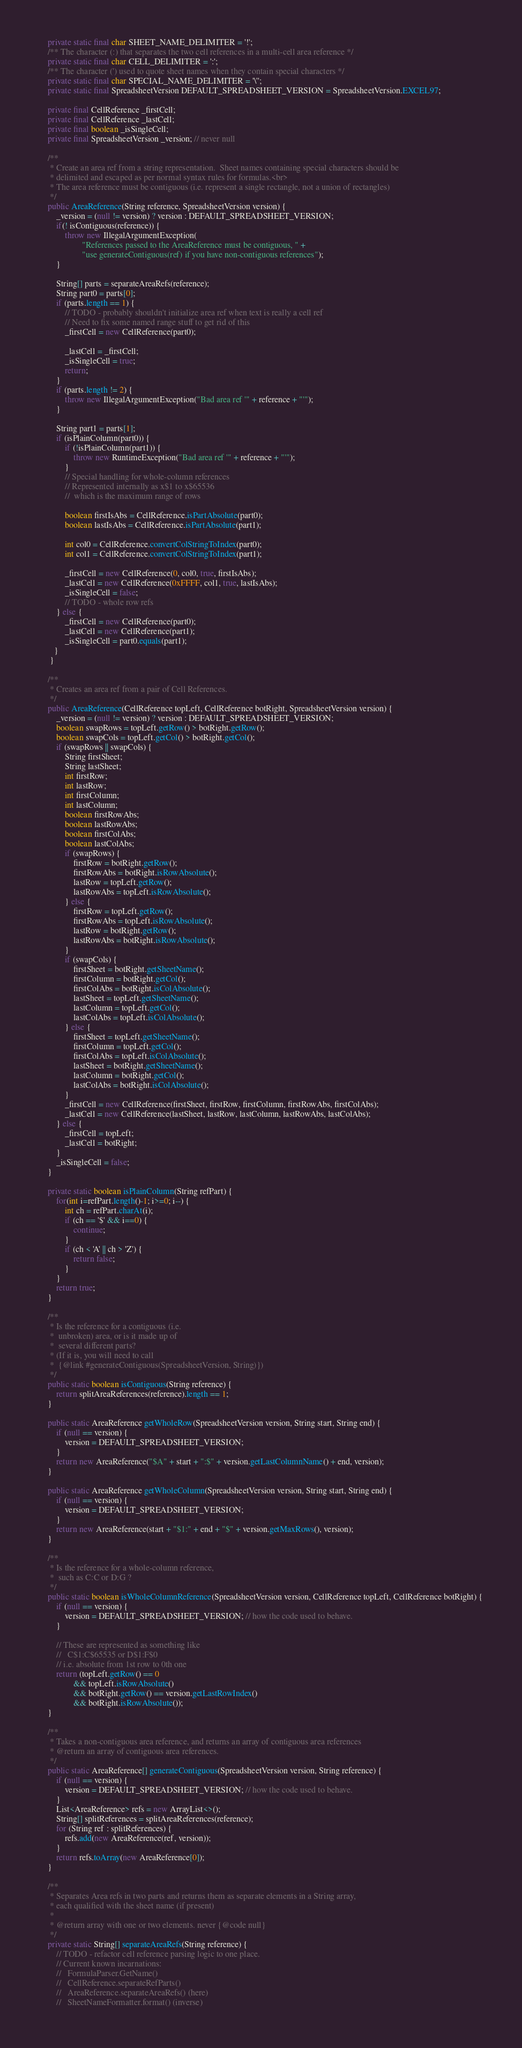<code> <loc_0><loc_0><loc_500><loc_500><_Java_>    private static final char SHEET_NAME_DELIMITER = '!';
    /** The character (:) that separates the two cell references in a multi-cell area reference */
    private static final char CELL_DELIMITER = ':';
    /** The character (') used to quote sheet names when they contain special characters */
    private static final char SPECIAL_NAME_DELIMITER = '\'';
    private static final SpreadsheetVersion DEFAULT_SPREADSHEET_VERSION = SpreadsheetVersion.EXCEL97;

    private final CellReference _firstCell;
    private final CellReference _lastCell;
    private final boolean _isSingleCell;
    private final SpreadsheetVersion _version; // never null

    /**
     * Create an area ref from a string representation.  Sheet names containing special characters should be
     * delimited and escaped as per normal syntax rules for formulas.<br>
     * The area reference must be contiguous (i.e. represent a single rectangle, not a union of rectangles)
     */
    public AreaReference(String reference, SpreadsheetVersion version) {
        _version = (null != version) ? version : DEFAULT_SPREADSHEET_VERSION;
        if(! isContiguous(reference)) {
            throw new IllegalArgumentException(
                    "References passed to the AreaReference must be contiguous, " +
                    "use generateContiguous(ref) if you have non-contiguous references");
        }

        String[] parts = separateAreaRefs(reference);
        String part0 = parts[0];
        if (parts.length == 1) {
            // TODO - probably shouldn't initialize area ref when text is really a cell ref
            // Need to fix some named range stuff to get rid of this
            _firstCell = new CellReference(part0);

            _lastCell = _firstCell;
            _isSingleCell = true;
            return;
        }
        if (parts.length != 2) {
            throw new IllegalArgumentException("Bad area ref '" + reference + "'");
        }

        String part1 = parts[1];
        if (isPlainColumn(part0)) {
            if (!isPlainColumn(part1)) {
                throw new RuntimeException("Bad area ref '" + reference + "'");
            }
            // Special handling for whole-column references
            // Represented internally as x$1 to x$65536
            //  which is the maximum range of rows

            boolean firstIsAbs = CellReference.isPartAbsolute(part0);
            boolean lastIsAbs = CellReference.isPartAbsolute(part1);

            int col0 = CellReference.convertColStringToIndex(part0);
            int col1 = CellReference.convertColStringToIndex(part1);

            _firstCell = new CellReference(0, col0, true, firstIsAbs);
            _lastCell = new CellReference(0xFFFF, col1, true, lastIsAbs);
            _isSingleCell = false;
            // TODO - whole row refs
        } else {
            _firstCell = new CellReference(part0);
            _lastCell = new CellReference(part1);
            _isSingleCell = part0.equals(part1);
       }
     }

    /**
     * Creates an area ref from a pair of Cell References.
     */
    public AreaReference(CellReference topLeft, CellReference botRight, SpreadsheetVersion version) {
        _version = (null != version) ? version : DEFAULT_SPREADSHEET_VERSION;
        boolean swapRows = topLeft.getRow() > botRight.getRow();
        boolean swapCols = topLeft.getCol() > botRight.getCol();
        if (swapRows || swapCols) {
            String firstSheet;
            String lastSheet;
            int firstRow;
            int lastRow;
            int firstColumn;
            int lastColumn;
            boolean firstRowAbs;
            boolean lastRowAbs;
            boolean firstColAbs;
            boolean lastColAbs;
            if (swapRows) {
                firstRow = botRight.getRow();
                firstRowAbs = botRight.isRowAbsolute();
                lastRow = topLeft.getRow();
                lastRowAbs = topLeft.isRowAbsolute();
            } else {
                firstRow = topLeft.getRow();
                firstRowAbs = topLeft.isRowAbsolute();
                lastRow = botRight.getRow();
                lastRowAbs = botRight.isRowAbsolute();
            }
            if (swapCols) {
                firstSheet = botRight.getSheetName();
                firstColumn = botRight.getCol();
                firstColAbs = botRight.isColAbsolute();
                lastSheet = topLeft.getSheetName();
                lastColumn = topLeft.getCol();
                lastColAbs = topLeft.isColAbsolute();
            } else {
                firstSheet = topLeft.getSheetName();
                firstColumn = topLeft.getCol();
                firstColAbs = topLeft.isColAbsolute();
                lastSheet = botRight.getSheetName();
                lastColumn = botRight.getCol();
                lastColAbs = botRight.isColAbsolute();
            }
            _firstCell = new CellReference(firstSheet, firstRow, firstColumn, firstRowAbs, firstColAbs);
            _lastCell = new CellReference(lastSheet, lastRow, lastColumn, lastRowAbs, lastColAbs);
        } else {
            _firstCell = topLeft;
            _lastCell = botRight;
        }
        _isSingleCell = false;
    }

    private static boolean isPlainColumn(String refPart) {
        for(int i=refPart.length()-1; i>=0; i--) {
            int ch = refPart.charAt(i);
            if (ch == '$' && i==0) {
                continue;
            }
            if (ch < 'A' || ch > 'Z') {
                return false;
            }
        }
        return true;
    }

    /**
     * Is the reference for a contiguous (i.e.
     *  unbroken) area, or is it made up of
     *  several different parts?
     * (If it is, you will need to call
     *  {@link #generateContiguous(SpreadsheetVersion, String)})
     */
    public static boolean isContiguous(String reference) {
        return splitAreaReferences(reference).length == 1;
    }

    public static AreaReference getWholeRow(SpreadsheetVersion version, String start, String end) {
        if (null == version) {
            version = DEFAULT_SPREADSHEET_VERSION;
        }
        return new AreaReference("$A" + start + ":$" + version.getLastColumnName() + end, version);
    }

    public static AreaReference getWholeColumn(SpreadsheetVersion version, String start, String end) {
        if (null == version) {
            version = DEFAULT_SPREADSHEET_VERSION;
        }
        return new AreaReference(start + "$1:" + end + "$" + version.getMaxRows(), version);
    }

    /**
     * Is the reference for a whole-column reference,
     *  such as C:C or D:G ?
     */
    public static boolean isWholeColumnReference(SpreadsheetVersion version, CellReference topLeft, CellReference botRight) {
        if (null == version) {
            version = DEFAULT_SPREADSHEET_VERSION; // how the code used to behave.
        }

        // These are represented as something like
        //   C$1:C$65535 or D$1:F$0
        // i.e. absolute from 1st row to 0th one
        return (topLeft.getRow() == 0
                && topLeft.isRowAbsolute()
                && botRight.getRow() == version.getLastRowIndex()
                && botRight.isRowAbsolute());
    }

    /**
     * Takes a non-contiguous area reference, and returns an array of contiguous area references
     * @return an array of contiguous area references.
     */
    public static AreaReference[] generateContiguous(SpreadsheetVersion version, String reference) {
        if (null == version) {
            version = DEFAULT_SPREADSHEET_VERSION; // how the code used to behave.
        }
        List<AreaReference> refs = new ArrayList<>();
        String[] splitReferences = splitAreaReferences(reference);
        for (String ref : splitReferences) {
            refs.add(new AreaReference(ref, version));
        }
        return refs.toArray(new AreaReference[0]);
    }

    /**
     * Separates Area refs in two parts and returns them as separate elements in a String array,
     * each qualified with the sheet name (if present)
     *
     * @return array with one or two elements. never {@code null}
     */
    private static String[] separateAreaRefs(String reference) {
        // TODO - refactor cell reference parsing logic to one place.
        // Current known incarnations:
        //   FormulaParser.GetName()
        //   CellReference.separateRefParts()
        //   AreaReference.separateAreaRefs() (here)
        //   SheetNameFormatter.format() (inverse)

</code> 